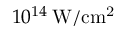<formula> <loc_0><loc_0><loc_500><loc_500>1 0 ^ { 1 4 } \, W / c m ^ { 2 }</formula> 